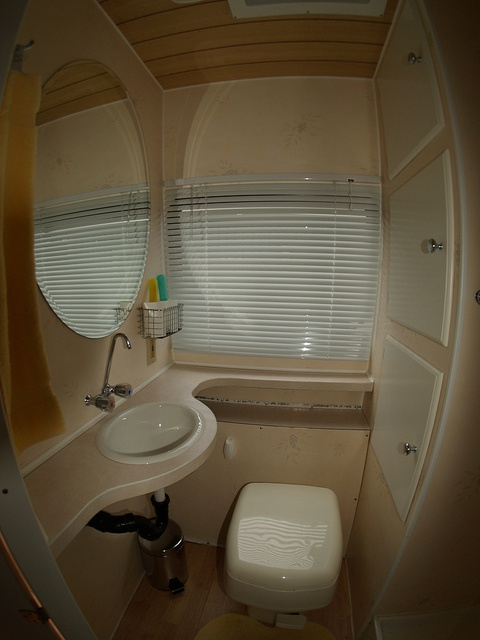Describe the objects in this image and their specific colors. I can see toilet in black, gray, and darkgray tones and sink in black and gray tones in this image. 